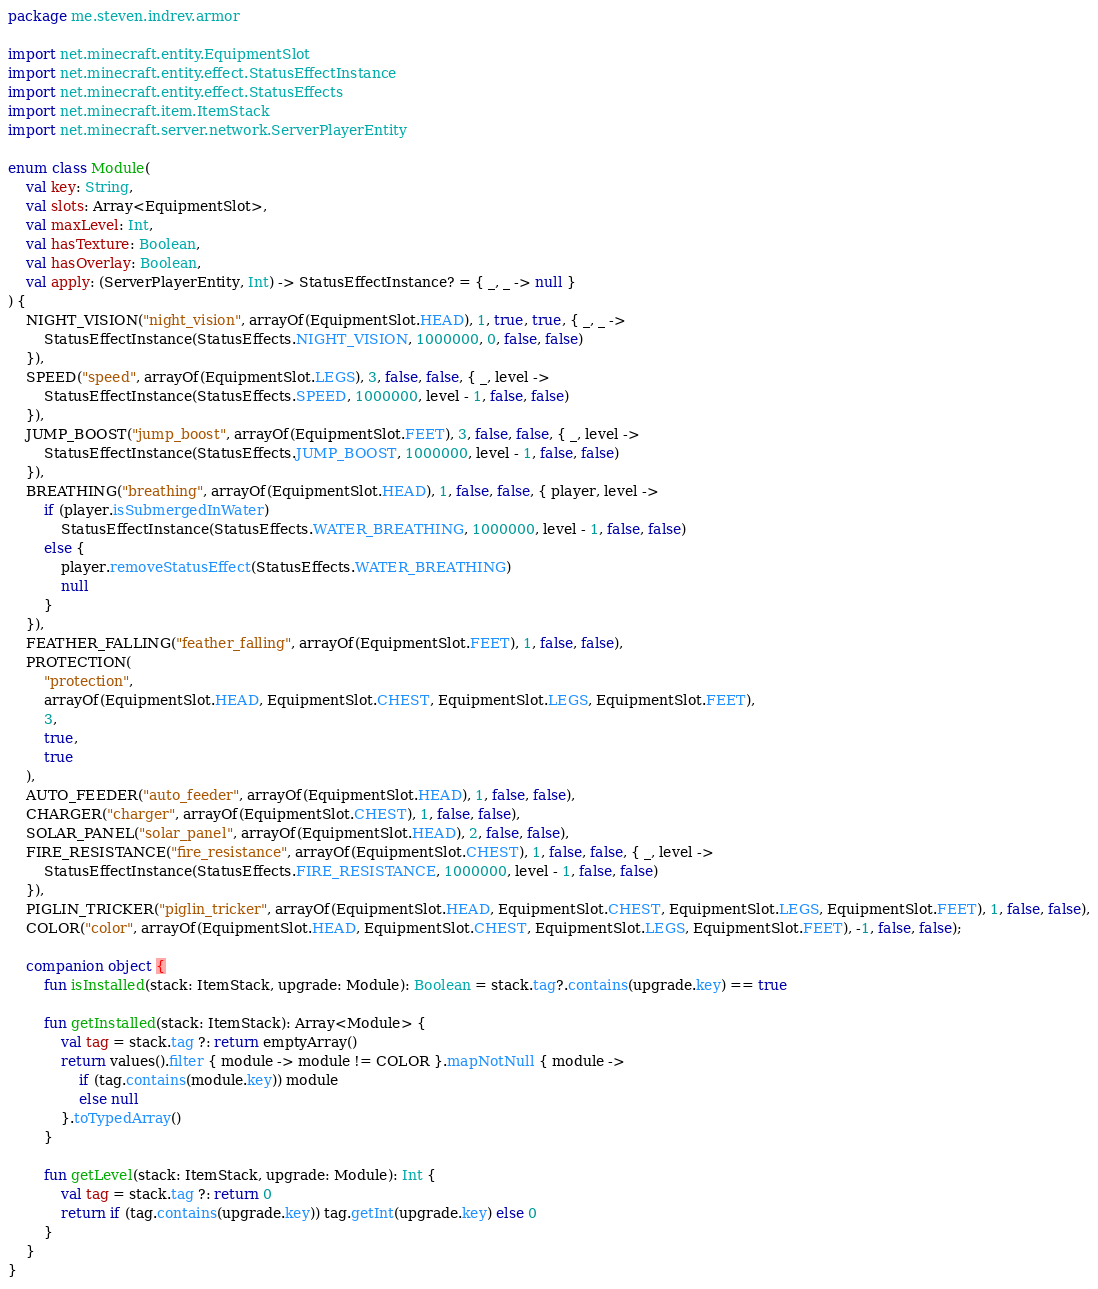Convert code to text. <code><loc_0><loc_0><loc_500><loc_500><_Kotlin_>package me.steven.indrev.armor

import net.minecraft.entity.EquipmentSlot
import net.minecraft.entity.effect.StatusEffectInstance
import net.minecraft.entity.effect.StatusEffects
import net.minecraft.item.ItemStack
import net.minecraft.server.network.ServerPlayerEntity

enum class Module(
    val key: String,
    val slots: Array<EquipmentSlot>,
    val maxLevel: Int,
    val hasTexture: Boolean,
    val hasOverlay: Boolean,
    val apply: (ServerPlayerEntity, Int) -> StatusEffectInstance? = { _, _ -> null }
) {
    NIGHT_VISION("night_vision", arrayOf(EquipmentSlot.HEAD), 1, true, true, { _, _ ->
        StatusEffectInstance(StatusEffects.NIGHT_VISION, 1000000, 0, false, false)
    }),
    SPEED("speed", arrayOf(EquipmentSlot.LEGS), 3, false, false, { _, level ->
        StatusEffectInstance(StatusEffects.SPEED, 1000000, level - 1, false, false)
    }),
    JUMP_BOOST("jump_boost", arrayOf(EquipmentSlot.FEET), 3, false, false, { _, level ->
        StatusEffectInstance(StatusEffects.JUMP_BOOST, 1000000, level - 1, false, false)
    }),
    BREATHING("breathing", arrayOf(EquipmentSlot.HEAD), 1, false, false, { player, level ->
        if (player.isSubmergedInWater)
            StatusEffectInstance(StatusEffects.WATER_BREATHING, 1000000, level - 1, false, false)
        else {
            player.removeStatusEffect(StatusEffects.WATER_BREATHING)
            null
        }
    }),
    FEATHER_FALLING("feather_falling", arrayOf(EquipmentSlot.FEET), 1, false, false),
    PROTECTION(
        "protection",
        arrayOf(EquipmentSlot.HEAD, EquipmentSlot.CHEST, EquipmentSlot.LEGS, EquipmentSlot.FEET),
        3,
        true,
        true
    ),
    AUTO_FEEDER("auto_feeder", arrayOf(EquipmentSlot.HEAD), 1, false, false),
    CHARGER("charger", arrayOf(EquipmentSlot.CHEST), 1, false, false),
    SOLAR_PANEL("solar_panel", arrayOf(EquipmentSlot.HEAD), 2, false, false),
    FIRE_RESISTANCE("fire_resistance", arrayOf(EquipmentSlot.CHEST), 1, false, false, { _, level ->
        StatusEffectInstance(StatusEffects.FIRE_RESISTANCE, 1000000, level - 1, false, false)
    }),
    PIGLIN_TRICKER("piglin_tricker", arrayOf(EquipmentSlot.HEAD, EquipmentSlot.CHEST, EquipmentSlot.LEGS, EquipmentSlot.FEET), 1, false, false),
    COLOR("color", arrayOf(EquipmentSlot.HEAD, EquipmentSlot.CHEST, EquipmentSlot.LEGS, EquipmentSlot.FEET), -1, false, false);

    companion object {
        fun isInstalled(stack: ItemStack, upgrade: Module): Boolean = stack.tag?.contains(upgrade.key) == true

        fun getInstalled(stack: ItemStack): Array<Module> {
            val tag = stack.tag ?: return emptyArray()
            return values().filter { module -> module != COLOR }.mapNotNull { module ->
                if (tag.contains(module.key)) module
                else null
            }.toTypedArray()
        }

        fun getLevel(stack: ItemStack, upgrade: Module): Int {
            val tag = stack.tag ?: return 0
            return if (tag.contains(upgrade.key)) tag.getInt(upgrade.key) else 0
        }
    }
}</code> 